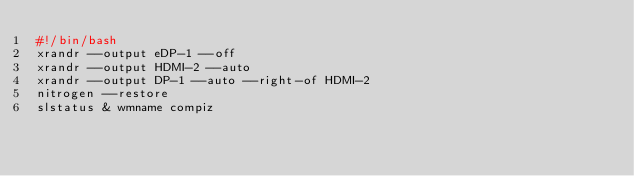Convert code to text. <code><loc_0><loc_0><loc_500><loc_500><_Bash_>#!/bin/bash
xrandr --output eDP-1 --off
xrandr --output HDMI-2 --auto
xrandr --output DP-1 --auto --right-of HDMI-2
nitrogen --restore
slstatus & wmname compiz

</code> 